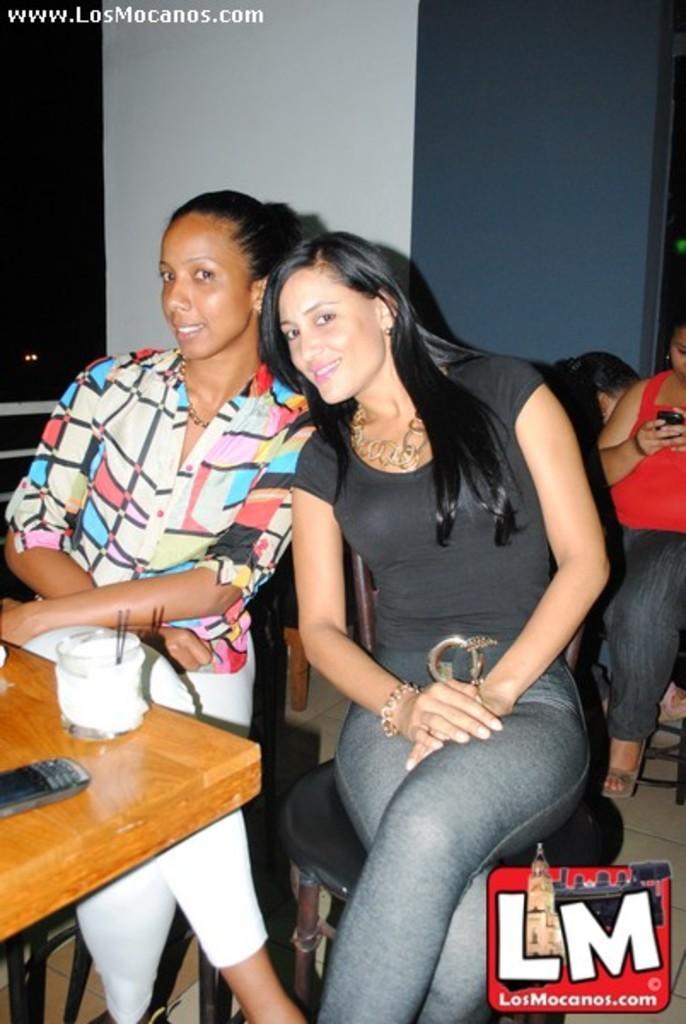Please provide a concise description of this image. This picture is clicked inside a room. On the left corner of this picture, there is woman who is sitting on the chair and smiling. In front of her, we see a table on which mobile phone and glass is placed. To the left of her, we see woman wearing black t-shirt and smiling, she is sitting on the chair. To the right corner of this picture, we see women wearing a red t-shirt is holding mobile phone in her hands. Behind her, we see blue wall. 